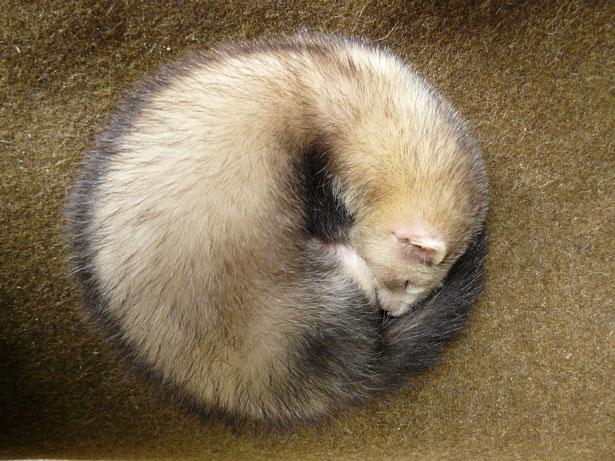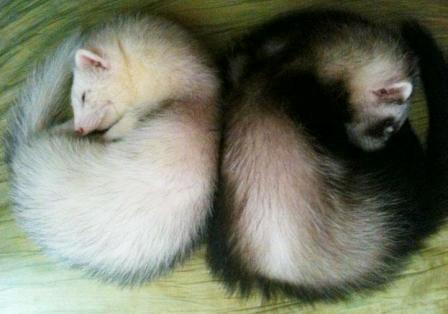The first image is the image on the left, the second image is the image on the right. Given the left and right images, does the statement "Three ferrets are sleeping." hold true? Answer yes or no. Yes. The first image is the image on the left, the second image is the image on the right. Evaluate the accuracy of this statement regarding the images: "In one of the images, exactly one ferret is sleeping with both eyes and mouth closed.". Is it true? Answer yes or no. Yes. 